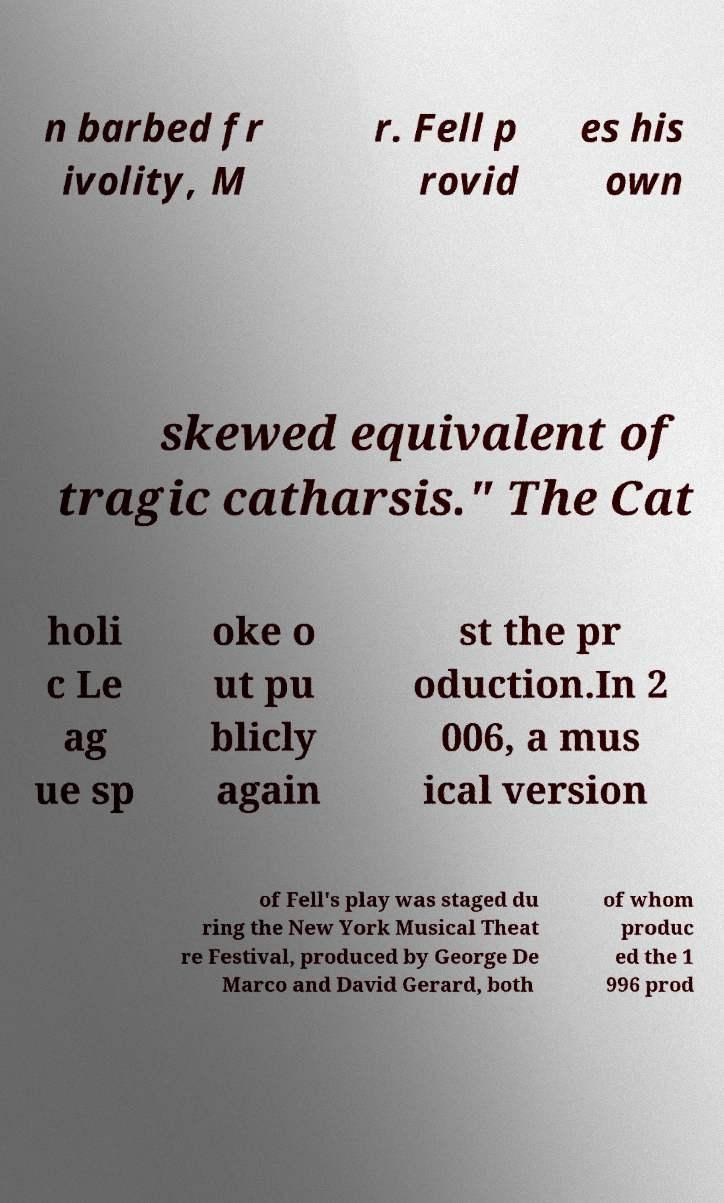For documentation purposes, I need the text within this image transcribed. Could you provide that? n barbed fr ivolity, M r. Fell p rovid es his own skewed equivalent of tragic catharsis." The Cat holi c Le ag ue sp oke o ut pu blicly again st the pr oduction.In 2 006, a mus ical version of Fell's play was staged du ring the New York Musical Theat re Festival, produced by George De Marco and David Gerard, both of whom produc ed the 1 996 prod 